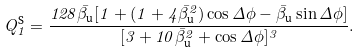Convert formula to latex. <formula><loc_0><loc_0><loc_500><loc_500>Q _ { 1 } ^ { \text {S} } = \frac { 1 2 8 \bar { \beta } _ { \text {u} } [ 1 + ( 1 + 4 { \bar { \beta } _ { \text {u} } } ^ { 2 } ) \cos \Delta \phi - { \bar { \beta } _ { \text {u} } } \sin \Delta \phi ] } { [ 3 + 1 0 { \bar { \beta } _ { \text {u} } } ^ { 2 } + \cos \Delta \phi ] ^ { 3 } } .</formula> 